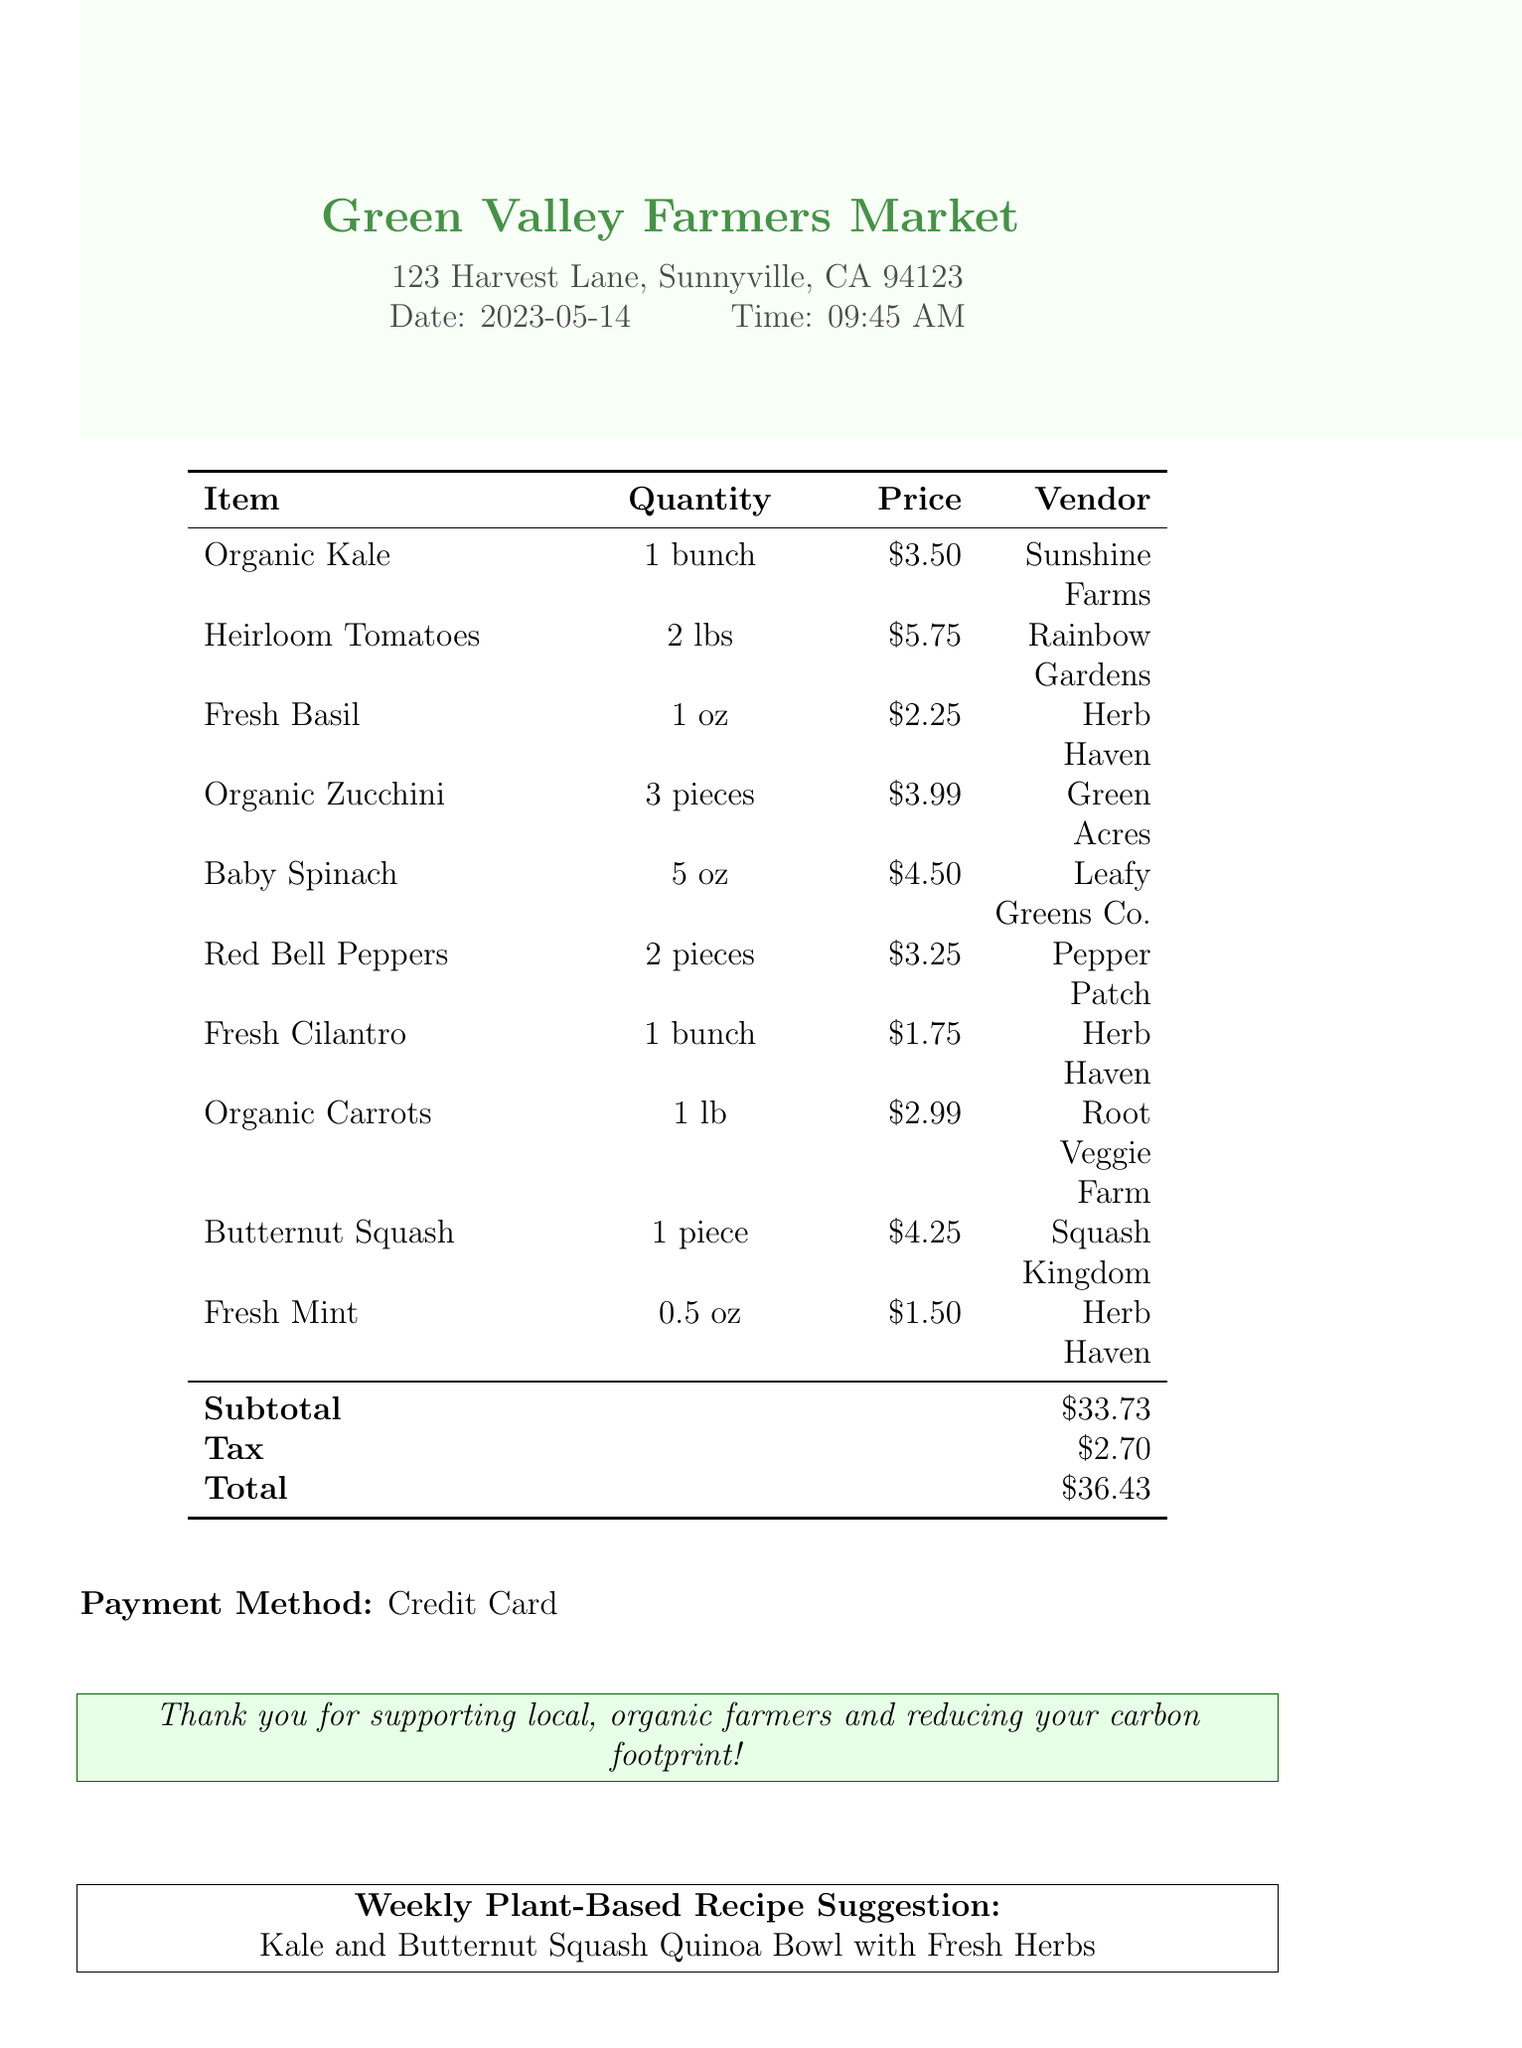What is the date of the market? The date of the market is listed in the receipt header.
Answer: 2023-05-14 How much did the butternut squash cost? The cost of butternut squash is provided in the list of items.
Answer: $4.25 Who is the vendor for the organic kale? The vendor for organic kale is mentioned next to the item.
Answer: Sunshine Farms What is the total amount spent? The total amount is calculated from the subtotal and tax provided at the end of the receipt.
Answer: $36.43 What is the quantity of fresh basil purchased? The quantity of fresh basil is specified in the items section of the receipt.
Answer: 1 oz What can we make with the purchased ingredients? The recipe suggestion provided at the bottom of the receipt hints at a possible dish.
Answer: Kale and Butternut Squash Quinoa Bowl with Fresh Herbs How much was the subtotal before tax? The subtotal is listed before the tax amount in the total section.
Answer: $33.73 Which vendor sells fresh cilantro? The vendor for fresh cilantro is noted in the items list.
Answer: Herb Haven What type of payment was used? The payment method is mentioned towards the end of the document.
Answer: Credit Card 